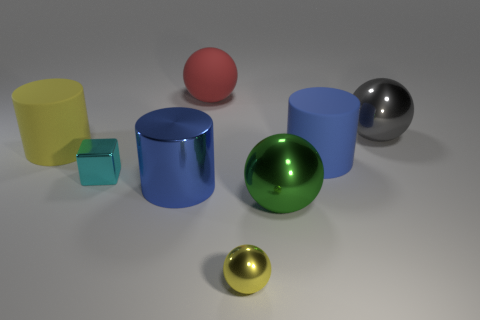Subtract 1 balls. How many balls are left? 3 Add 1 metal balls. How many objects exist? 9 Subtract all cylinders. How many objects are left? 5 Subtract 0 cyan cylinders. How many objects are left? 8 Subtract all large gray rubber cylinders. Subtract all large blue metal cylinders. How many objects are left? 7 Add 2 large green shiny things. How many large green shiny things are left? 3 Add 1 large yellow cubes. How many large yellow cubes exist? 1 